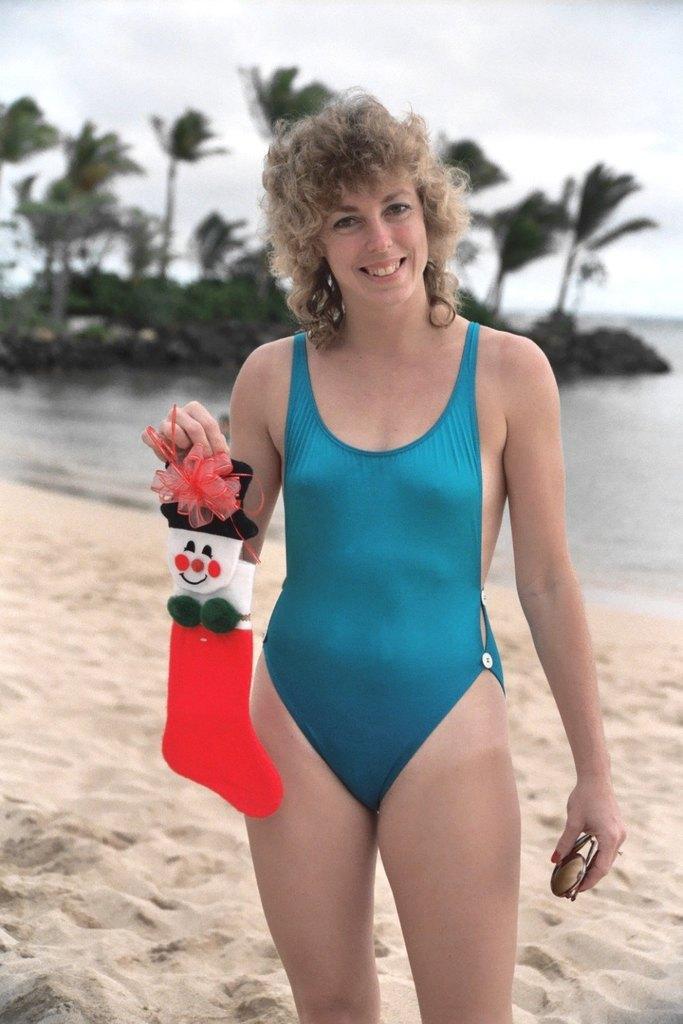How would you summarize this image in a sentence or two? This image is taken at the seashore. At the center of the image there is a lady holding an object on the both hands and standing on the sand. In the background of the image there is a river, trees and sky. 